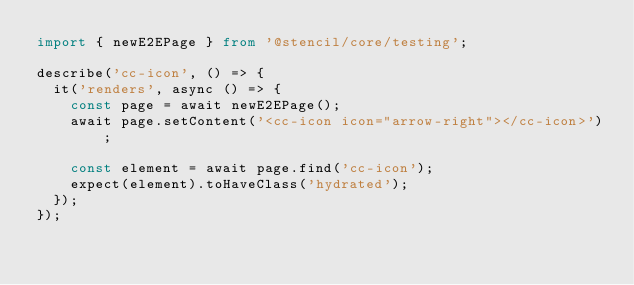<code> <loc_0><loc_0><loc_500><loc_500><_TypeScript_>import { newE2EPage } from '@stencil/core/testing';

describe('cc-icon', () => {
  it('renders', async () => {
    const page = await newE2EPage();
    await page.setContent('<cc-icon icon="arrow-right"></cc-icon>');

    const element = await page.find('cc-icon');
    expect(element).toHaveClass('hydrated');
  });
});
</code> 